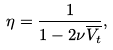Convert formula to latex. <formula><loc_0><loc_0><loc_500><loc_500>\eta = \frac { 1 } { 1 - 2 \nu \overline { V _ { t } } } ,</formula> 